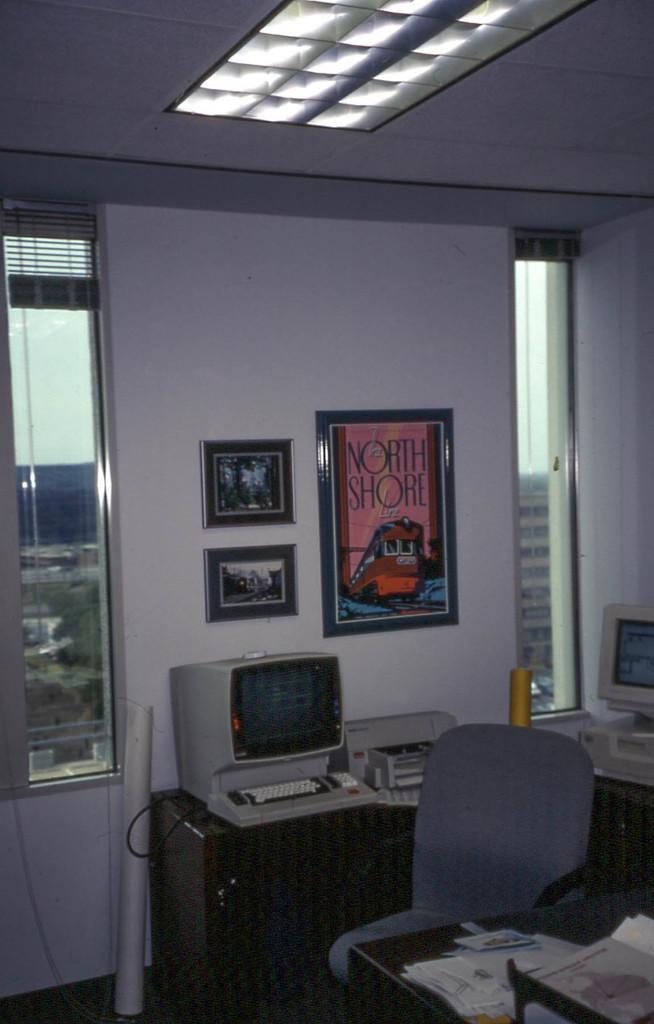<image>
Offer a succinct explanation of the picture presented. a poster with North Shore written on it 